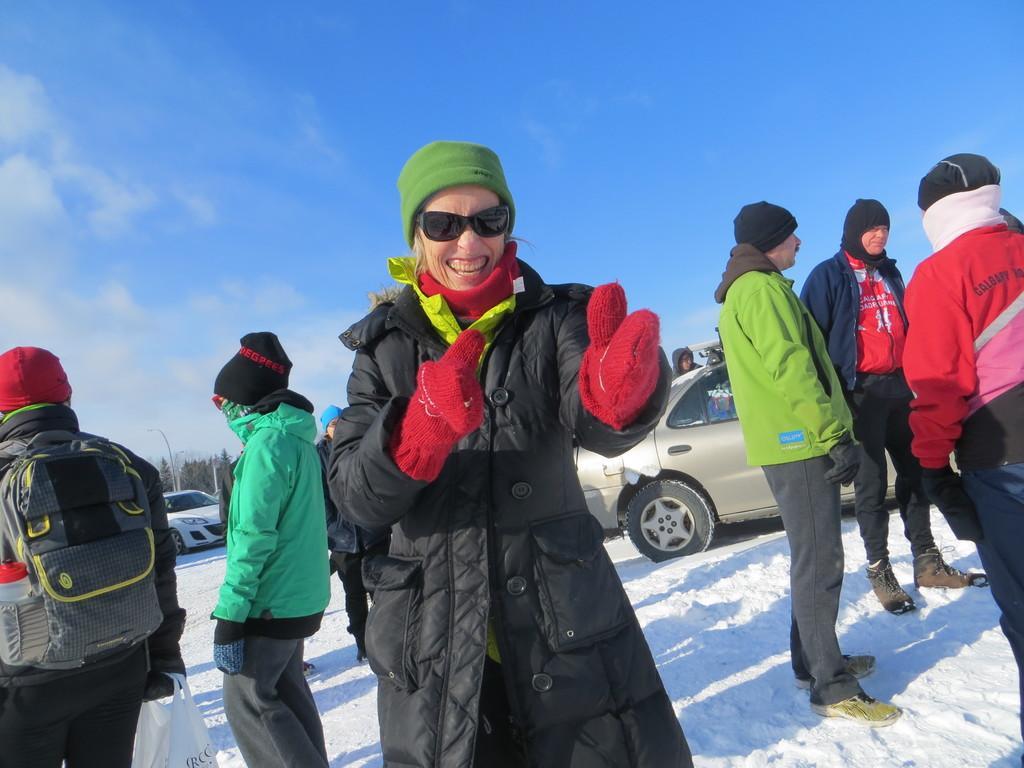Could you give a brief overview of what you see in this image? In this image I can see a person standing on snow and wearing black jacket, red gloves. At the back I can see few other persons standing, few vehicles and the sky is in white and blue color. 